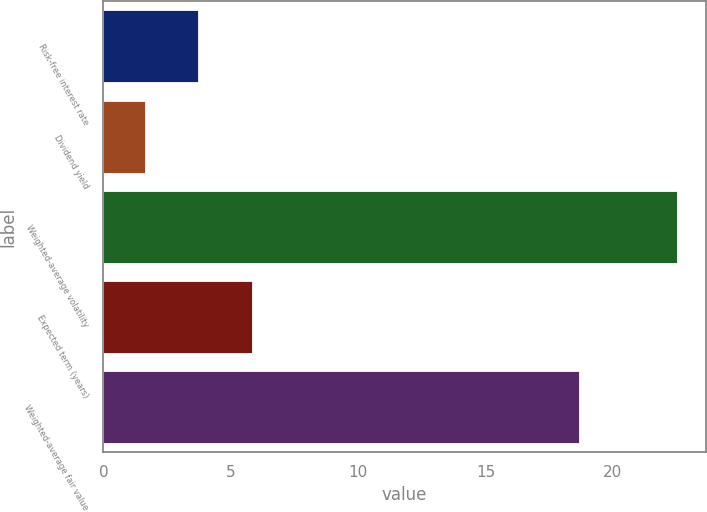Convert chart. <chart><loc_0><loc_0><loc_500><loc_500><bar_chart><fcel>Risk-free interest rate<fcel>Dividend yield<fcel>Weighted-average volatility<fcel>Expected term (years)<fcel>Weighted-average fair value<nl><fcel>3.73<fcel>1.64<fcel>22.52<fcel>5.82<fcel>18.66<nl></chart> 